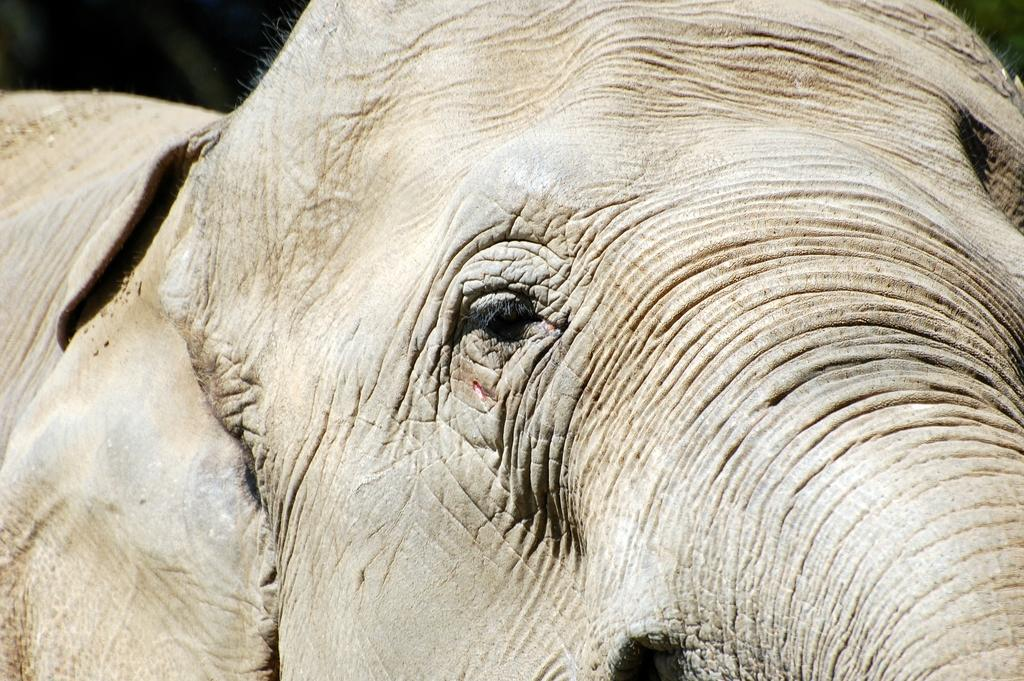What type of animal is in the image? There is an elephant in the image. What scent can be detected coming from the baby elephant in the image? There is no baby elephant present in the image, and therefore no scent can be detected. 